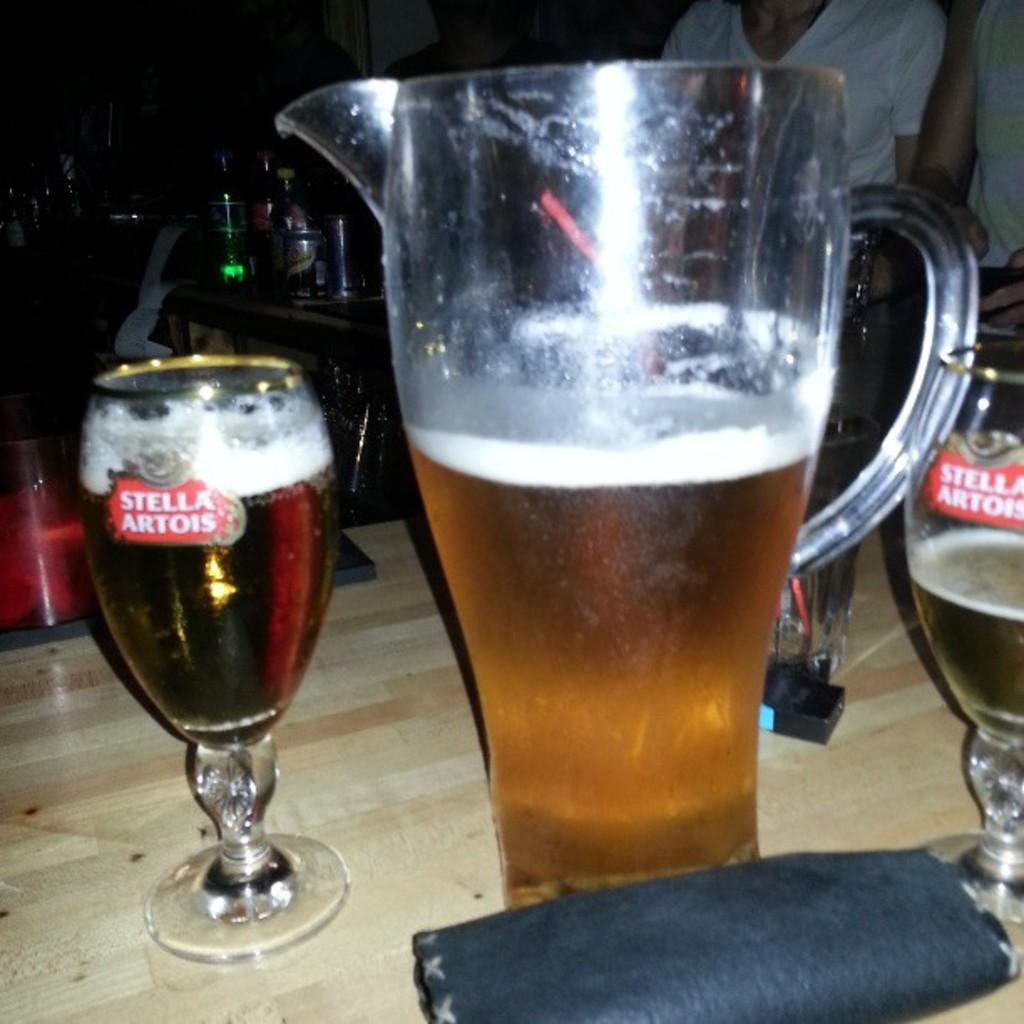Provide a one-sentence caption for the provided image. A pitcher of beer has been poured into Stella Artois glasses. 